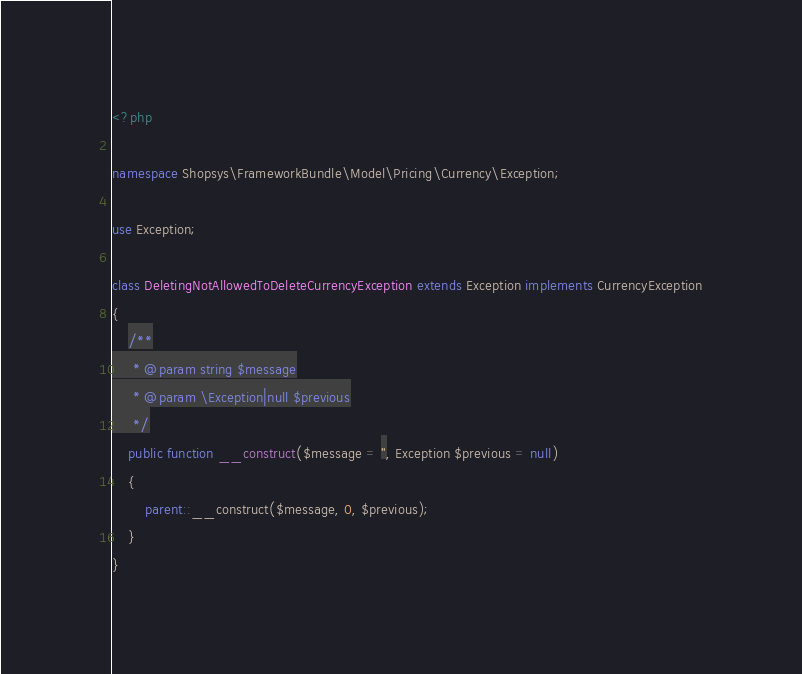Convert code to text. <code><loc_0><loc_0><loc_500><loc_500><_PHP_><?php

namespace Shopsys\FrameworkBundle\Model\Pricing\Currency\Exception;

use Exception;

class DeletingNotAllowedToDeleteCurrencyException extends Exception implements CurrencyException
{
    /**
     * @param string $message
     * @param \Exception|null $previous
     */
    public function __construct($message = '', Exception $previous = null)
    {
        parent::__construct($message, 0, $previous);
    }
}
</code> 